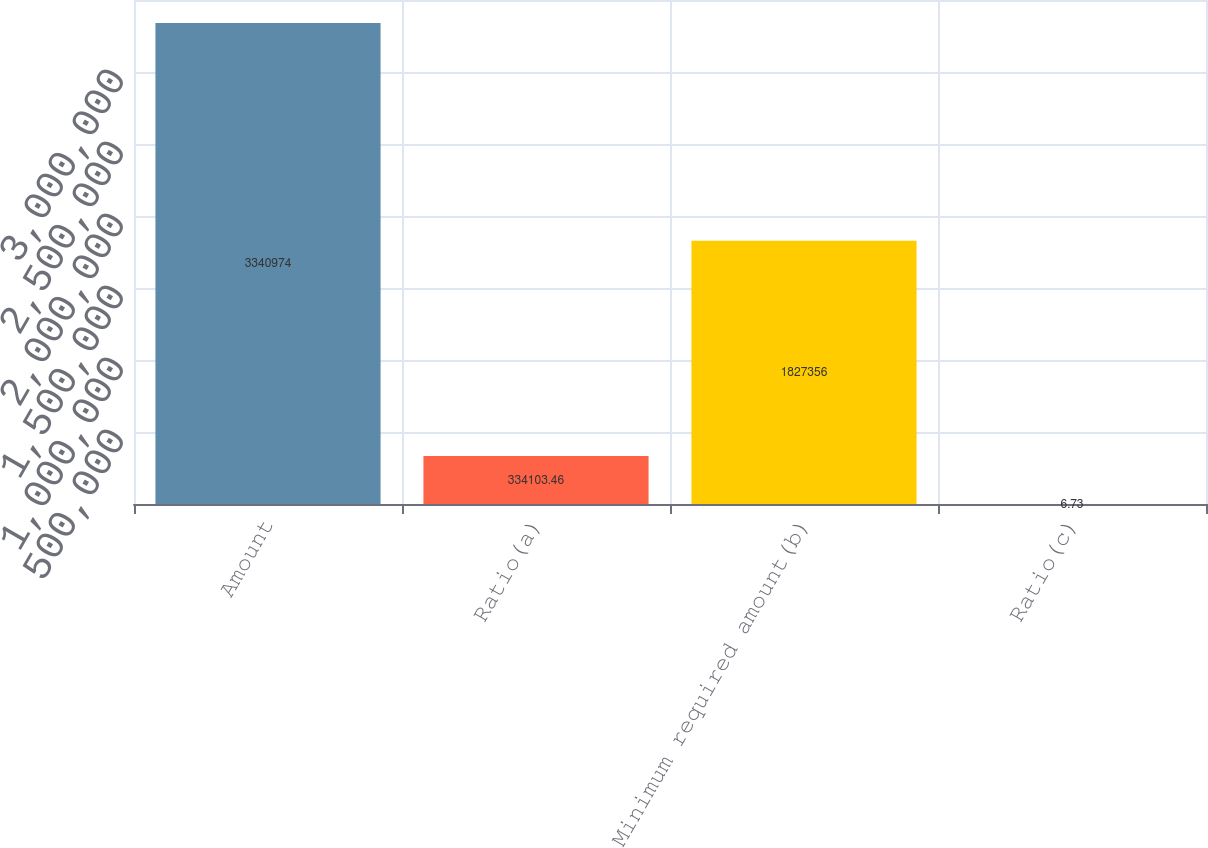Convert chart to OTSL. <chart><loc_0><loc_0><loc_500><loc_500><bar_chart><fcel>Amount<fcel>Ratio(a)<fcel>Minimum required amount(b)<fcel>Ratio(c)<nl><fcel>3.34097e+06<fcel>334103<fcel>1.82736e+06<fcel>6.73<nl></chart> 